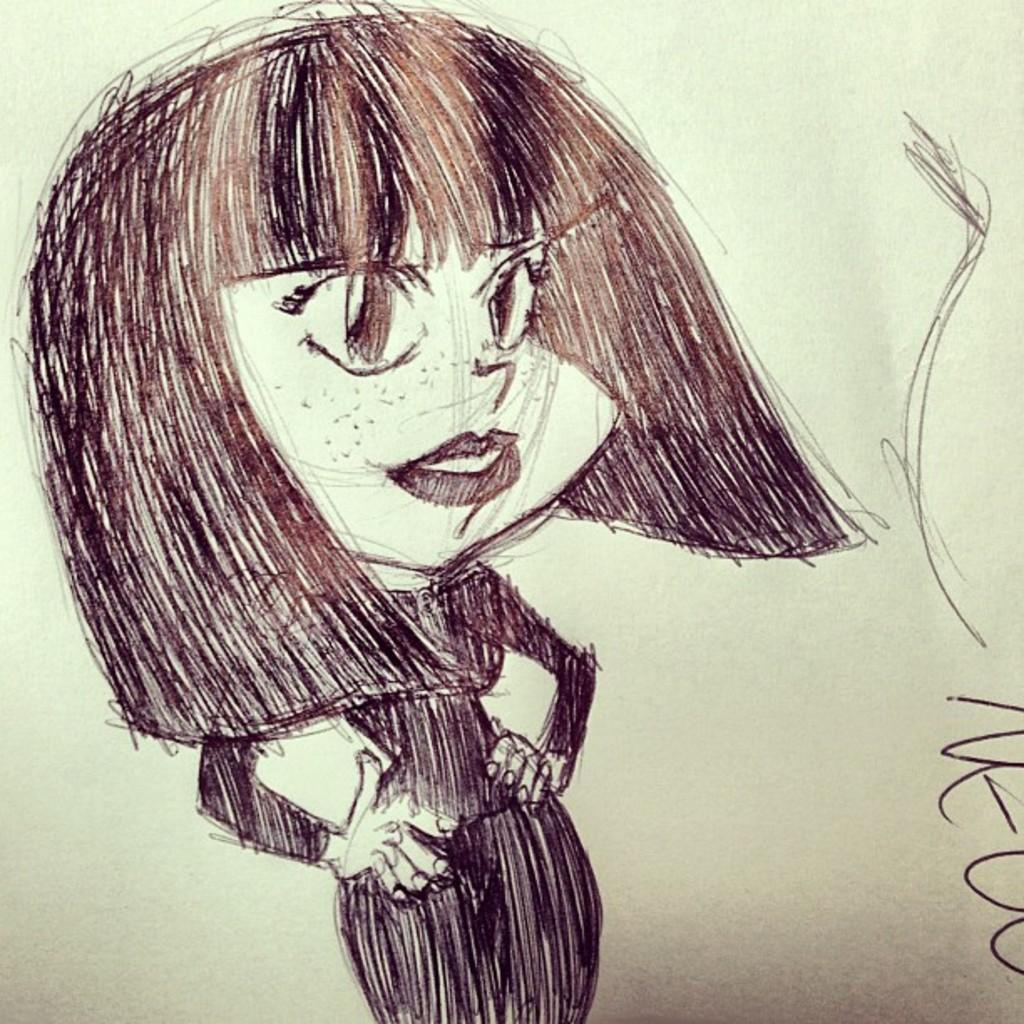Could you give a brief overview of what you see in this image? In this image I can see sketch painting of a girl. I can see colour of this image is black and white. 